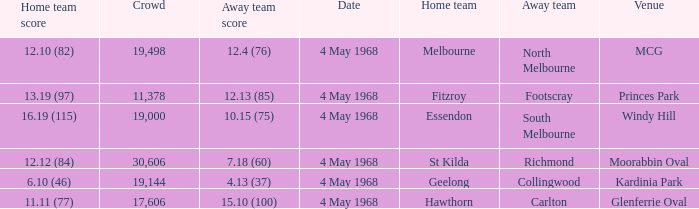13 (37)? 19144.0. 